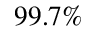Convert formula to latex. <formula><loc_0><loc_0><loc_500><loc_500>9 9 . 7 \%</formula> 